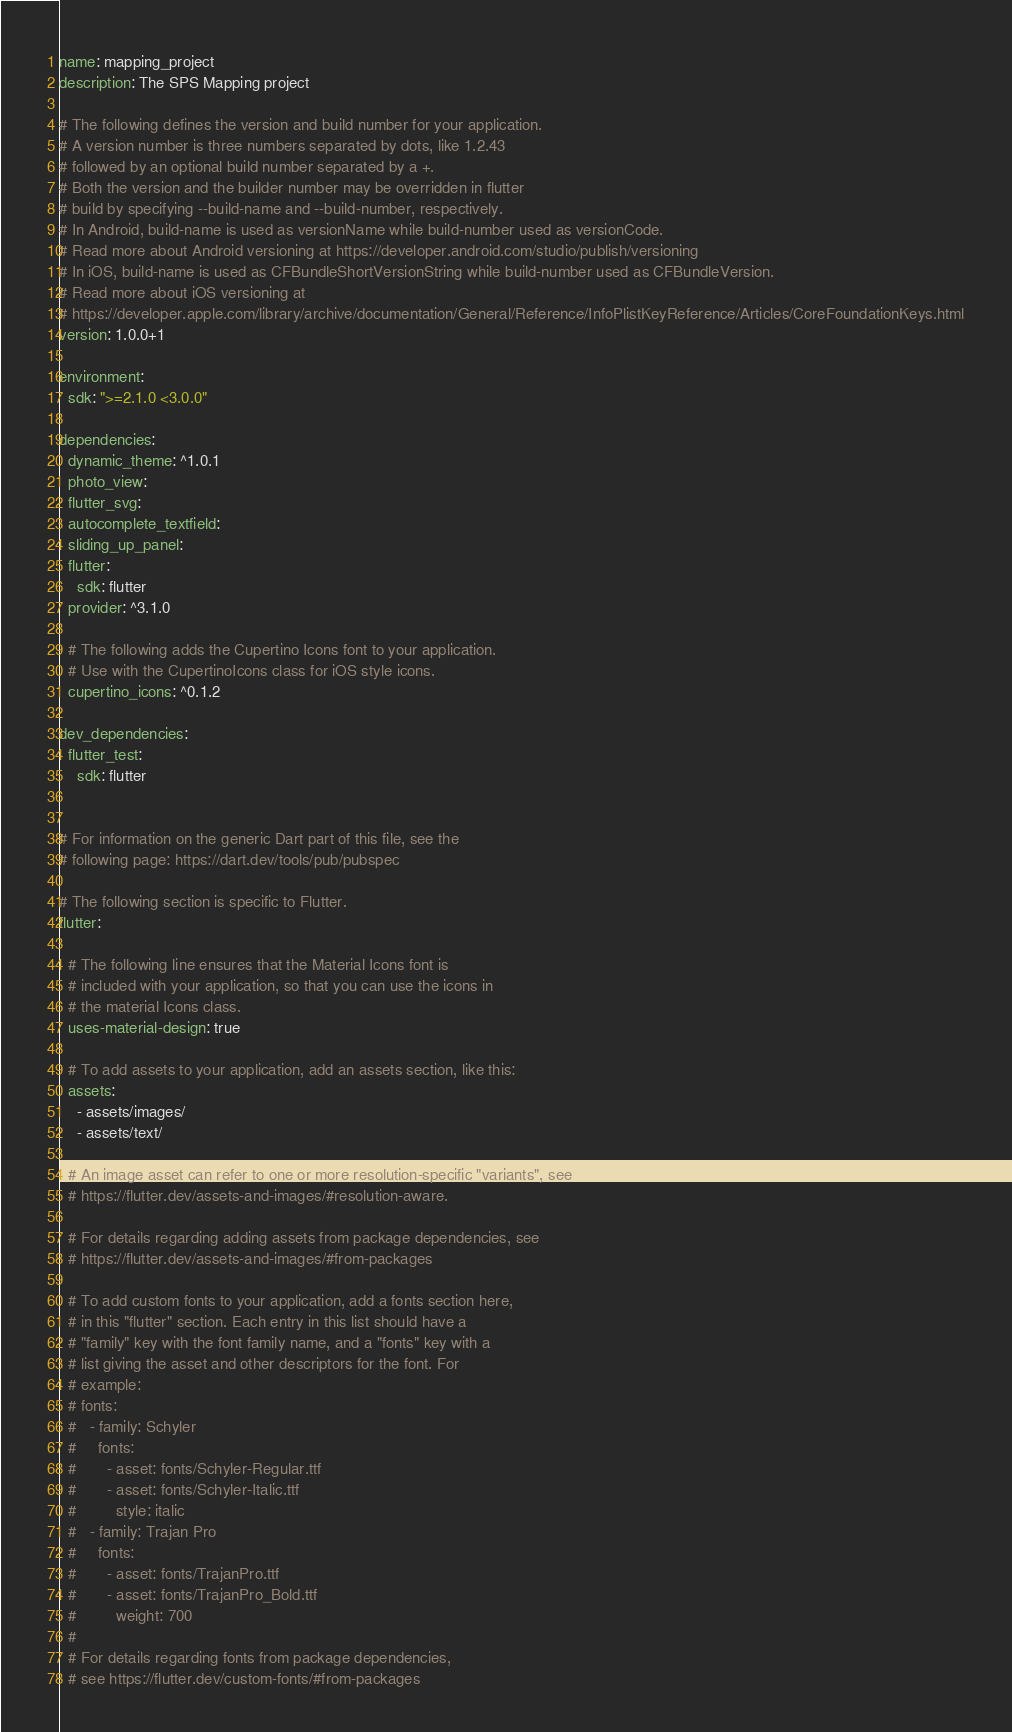<code> <loc_0><loc_0><loc_500><loc_500><_YAML_>name: mapping_project
description: The SPS Mapping project

# The following defines the version and build number for your application.
# A version number is three numbers separated by dots, like 1.2.43
# followed by an optional build number separated by a +.
# Both the version and the builder number may be overridden in flutter
# build by specifying --build-name and --build-number, respectively.
# In Android, build-name is used as versionName while build-number used as versionCode.
# Read more about Android versioning at https://developer.android.com/studio/publish/versioning
# In iOS, build-name is used as CFBundleShortVersionString while build-number used as CFBundleVersion.
# Read more about iOS versioning at
# https://developer.apple.com/library/archive/documentation/General/Reference/InfoPlistKeyReference/Articles/CoreFoundationKeys.html
version: 1.0.0+1

environment:
  sdk: ">=2.1.0 <3.0.0"

dependencies:
  dynamic_theme: ^1.0.1
  photo_view:
  flutter_svg:
  autocomplete_textfield:
  sliding_up_panel:
  flutter:
    sdk: flutter
  provider: ^3.1.0

  # The following adds the Cupertino Icons font to your application.
  # Use with the CupertinoIcons class for iOS style icons.
  cupertino_icons: ^0.1.2

dev_dependencies:
  flutter_test:
    sdk: flutter


# For information on the generic Dart part of this file, see the
# following page: https://dart.dev/tools/pub/pubspec

# The following section is specific to Flutter.
flutter:

  # The following line ensures that the Material Icons font is
  # included with your application, so that you can use the icons in
  # the material Icons class.
  uses-material-design: true

  # To add assets to your application, add an assets section, like this:
  assets:
    - assets/images/
    - assets/text/

  # An image asset can refer to one or more resolution-specific "variants", see
  # https://flutter.dev/assets-and-images/#resolution-aware.

  # For details regarding adding assets from package dependencies, see
  # https://flutter.dev/assets-and-images/#from-packages

  # To add custom fonts to your application, add a fonts section here,
  # in this "flutter" section. Each entry in this list should have a
  # "family" key with the font family name, and a "fonts" key with a
  # list giving the asset and other descriptors for the font. For
  # example:
  # fonts:
  #   - family: Schyler
  #     fonts:
  #       - asset: fonts/Schyler-Regular.ttf
  #       - asset: fonts/Schyler-Italic.ttf
  #         style: italic
  #   - family: Trajan Pro
  #     fonts:
  #       - asset: fonts/TrajanPro.ttf
  #       - asset: fonts/TrajanPro_Bold.ttf
  #         weight: 700
  #
  # For details regarding fonts from package dependencies,
  # see https://flutter.dev/custom-fonts/#from-packages
</code> 